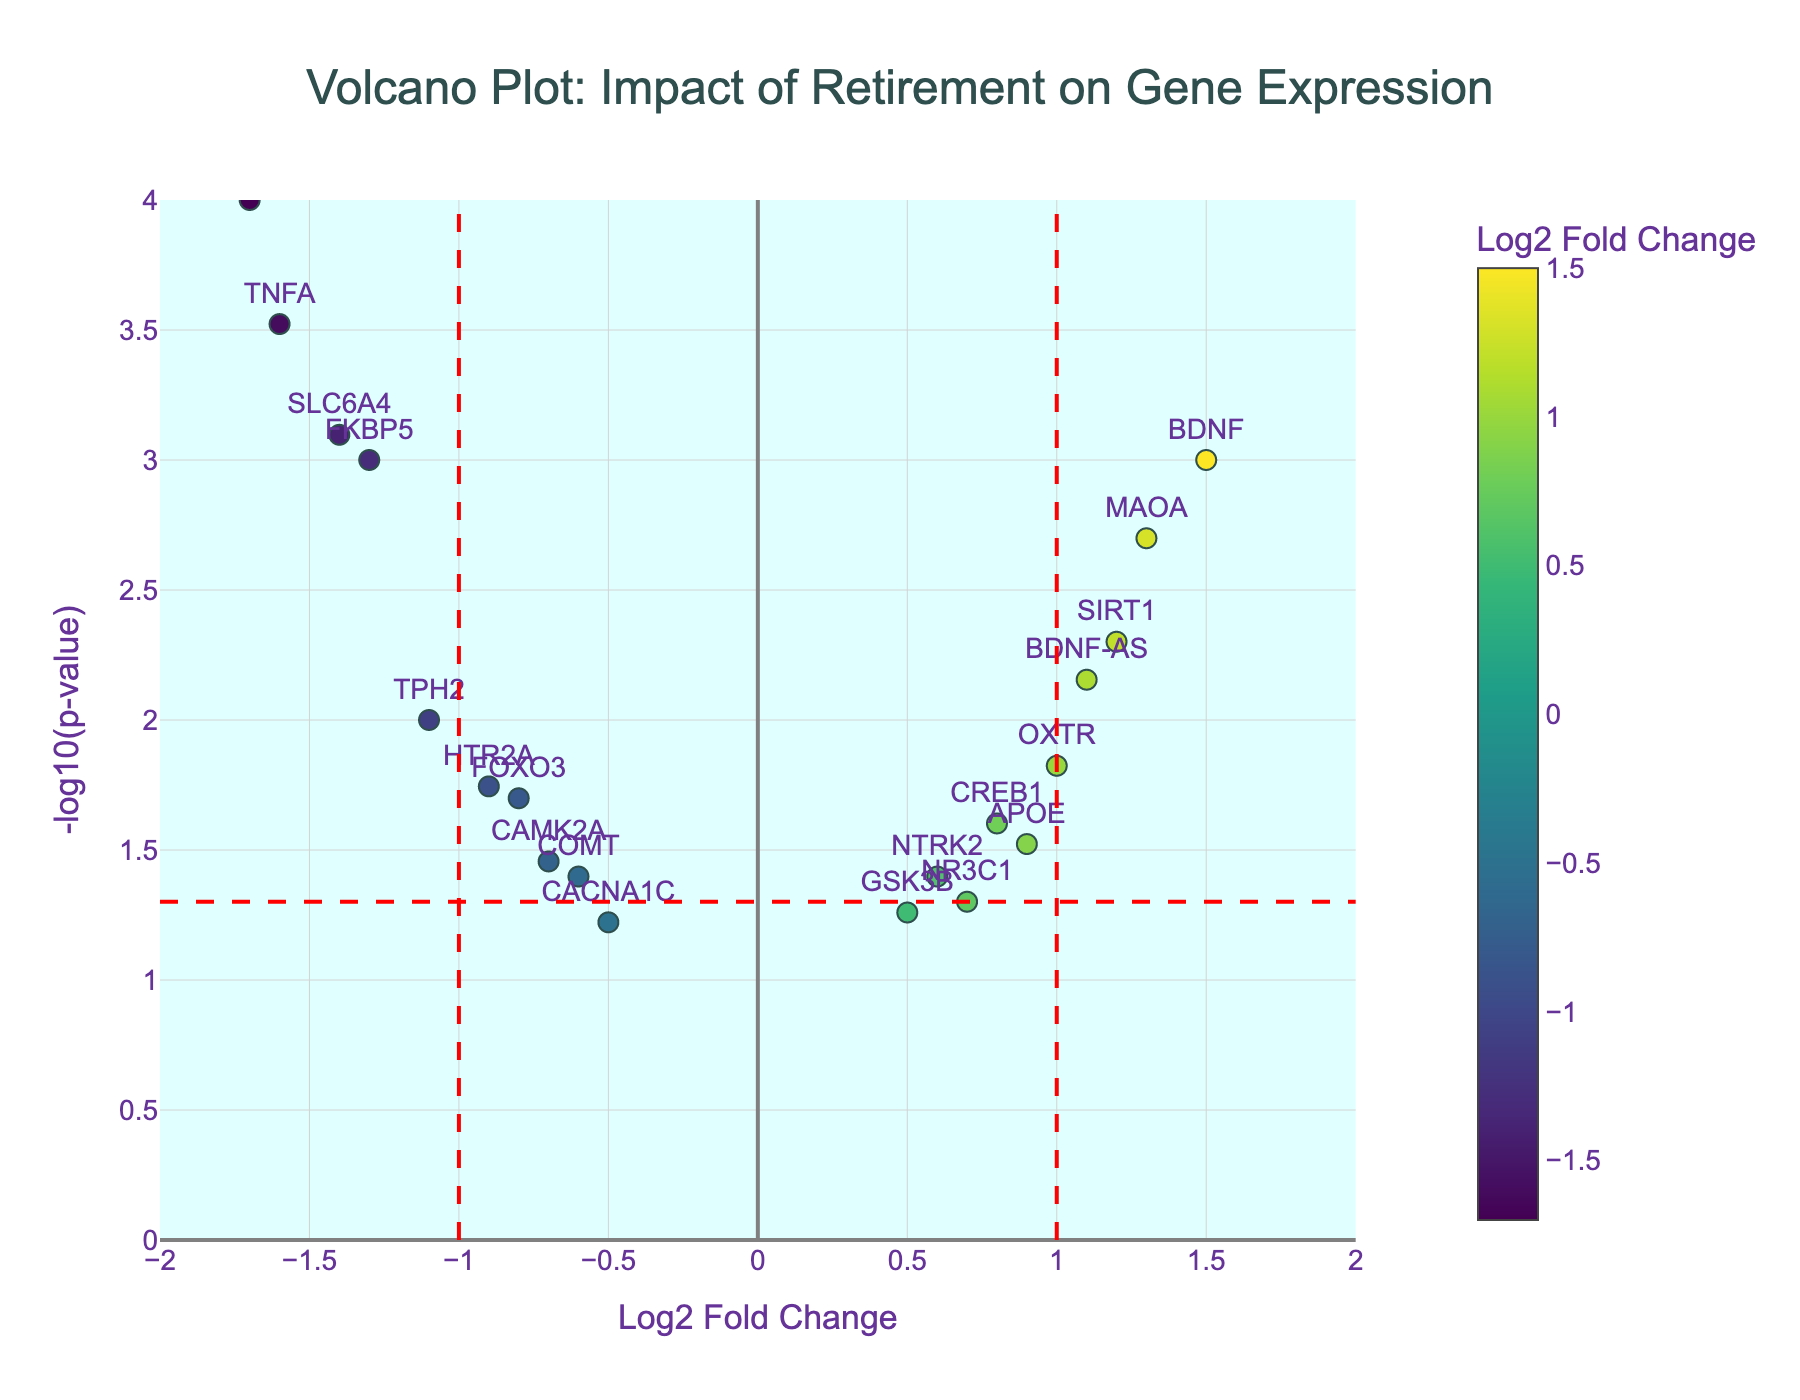How many genes are shown in the Volcano Plot? Count the number of data points (markers) visible in the plot. Since each data point corresponds to a different gene, the number of genes is the same as the number of data points.
Answer: 20 What are the axes labels of this Volcano Plot? Read the labels on the X-axis and Y-axis to understand what they represent.
Answer: The X-axis is "Log2 Fold Change" and the Y-axis is "-log10(p-value)" Which gene has the largest positive Log2 Fold Change? Look for the gene with the highest value on the X-axis (most to the right). This corresponds to the largest positive Log2 Fold Change.
Answer: BDNF Which gene has the smallest p-value? Identify the gene with the highest value on the Y-axis since -log10(p-value) inversely represents the p-value. A higher Y-coordinate means a lower p-value.
Answer: IL6 How many genes are significantly upregulated (Log2 Fold Change > 1 and p-value < 0.05)? Count the number of data points that are above the red horizontal line (indicating p-value < 0.05) and to the right of the red vertical line at Log2 Fold Change = 1.
Answer: 2 What is the Log2 Fold Change and p-value of the gene SIRT1? Find the data point corresponding to SIRT1 and read its X (Log2 Fold Change) and Y (-log10(p-value)) coordinates, then convert the Y value to p-value using the formula \( p = 10^{-\text{log10(p-value)}} \). SIRT1 is located at Log2 Fold Change = 1.2 and -log10(p-value) ≈ 2.3. Calculate the p-value by \( p = 10^{-2.3} \).
Answer: Log2 Fold Change: 1.2, p-value: 0.005 Which gene has a Log2 Fold Change closest to zero but still significantly different? Look for the gene whose marker is closest to the vertical red line at Log2 Fold Change = 0 but is situated above the horizontal red line (p-value < 0.05). This gene will be NR3C1 because its Log2 Fold Change is 0.7, the closest positive value to 0.
Answer: NR3C1 Compare the significance between TPH2 and TNFA based on their p-values. Which one is more significant? Both genes' p-values can be compared directly by their -log10(p-value) values. The gene with a higher -log10(p-value) is more significant since it corresponds to a smaller p-value. TNFA has a higher -log10(p-value) than TPH2.
Answer: TNFA How many genes have Log2 Fold Change between -1 and 1 and are not significant (p-value > 0.05)? Count the data points that lie within the range of -1 < Log2 Fold Change < 1 and below the horizontal red line (indicating p-value > 0.05).
Answer: 2 